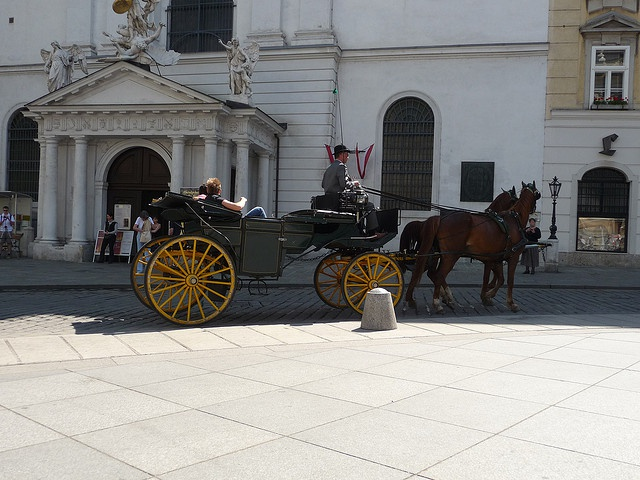Describe the objects in this image and their specific colors. I can see horse in gray, black, and darkgray tones, horse in gray, black, and purple tones, people in gray, black, and maroon tones, people in gray, black, white, and brown tones, and people in gray and black tones in this image. 